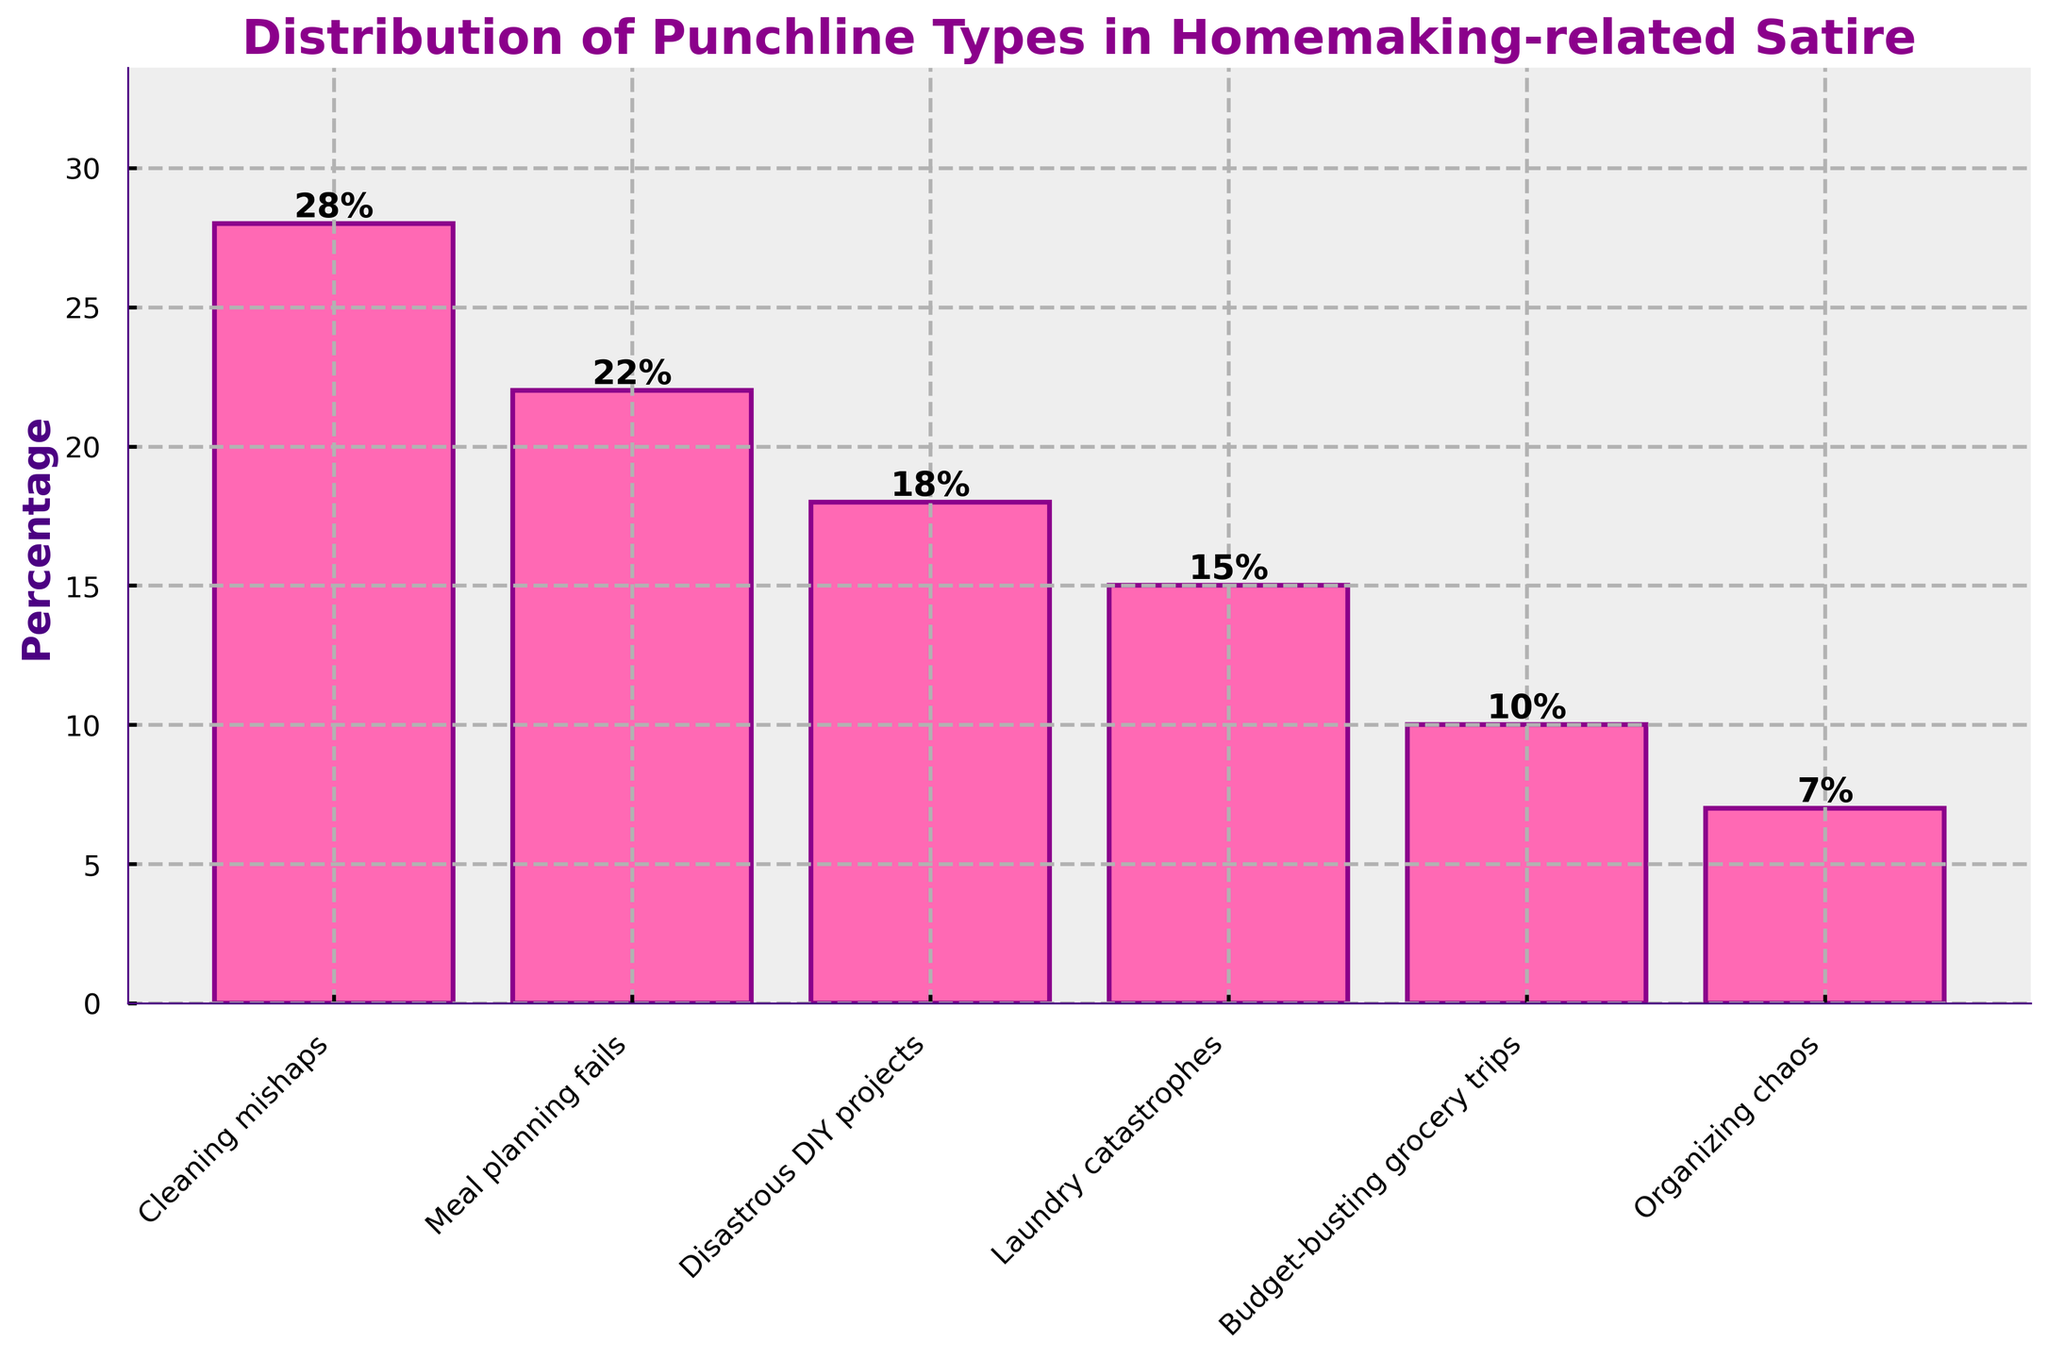Which category has the highest percentage of punchlines? Identify the category with the tallest bar. "Cleaning mishaps" has the tallest bar with a percentage of 28%.
Answer: Cleaning mishaps How much higher is the percentage of "Cleaning mishaps" punchlines compared to "Organizing chaos"? Subtract the percentage of "Organizing chaos" (7%) from "Cleaning mishaps" (28%): 28% - 7% = 21%
Answer: 21% What is the combined percentage of "Meal planning fails" and "Disastrous DIY projects"? Add the percentages of "Meal planning fails" (22%) and "Disastrous DIY projects" (18%): 22% + 18% = 40%
Answer: 40% Which category has the lowest percentage of punchlines? Identify the category with the shortest bar. "Organizing chaos" has the shortest bar with a percentage of 7%.
Answer: Organizing chaos By how much does "Laundry catastrophes" exceed "Budget-busting grocery trips" in percentage? Subtract the percentage of "Budget-busting grocery trips" (10%) from "Laundry catastrophes" (15%): 15% - 10% = 5%
Answer: 5% What are the two middle values in the dataset when the categories are ordered by percentage? When ordered by percentage: 7%, 10%, 15%, 18%, 22%, 28%. Middle values are 15% and 18%.
Answer: 15% and 18% Is the combined percentage of "Budget-busting grocery trips" and "Organizing chaos" less than "Meal planning fails"? Add the percentages of "Budget-busting grocery trips" (10%) and "Organizing chaos" (7%): 10% + 7% = 17%. Compare with "Meal planning fails" (22%): 17% < 22%
Answer: Yes What is the average percentage of all the categories combined? Sum the percentages: (28% + 22% + 18% + 15% + 10% + 7%) = 100%, then divide by the number of categories (6): 100% / 6 ≈ 16.67%
Answer: 16.67% What percentage of punchlines is encompassed by the three highest categories? Identify the three highest categories: "Cleaning mishaps" (28%), "Meal planning fails" (22%), "Disastrous DIY projects" (18%). Add them: 28% + 22% + 18% = 68%
Answer: 68% If the percentage of "Cleaning mishaps" were reduced by 5%, what would be the new percentage? Subtract 5% from "Cleaning mishaps": 28% - 5% = 23%
Answer: 23% 